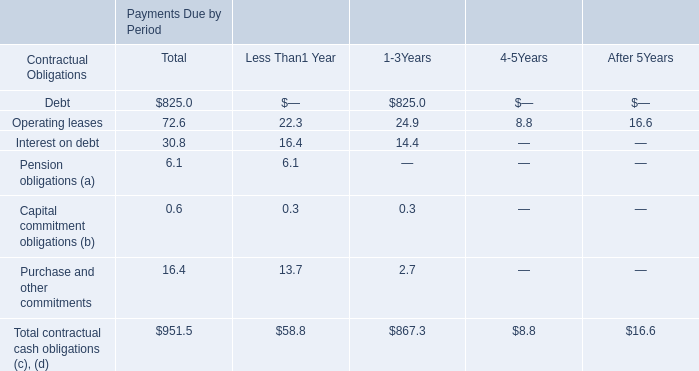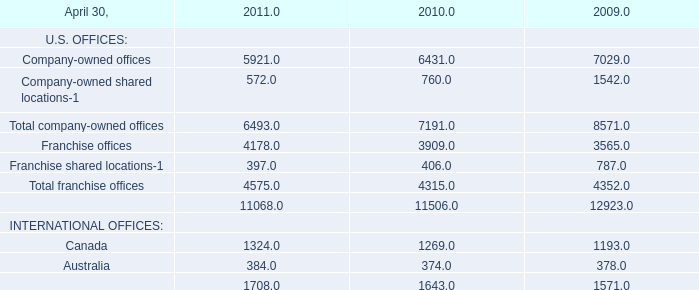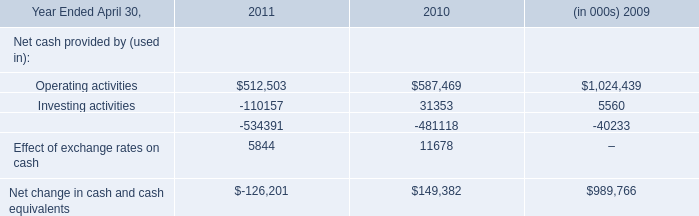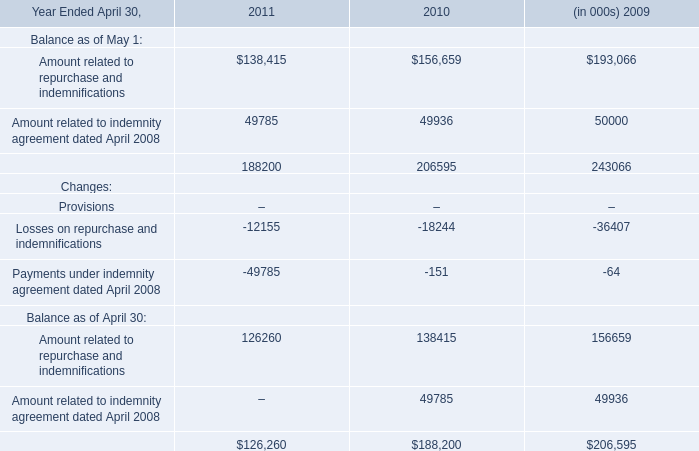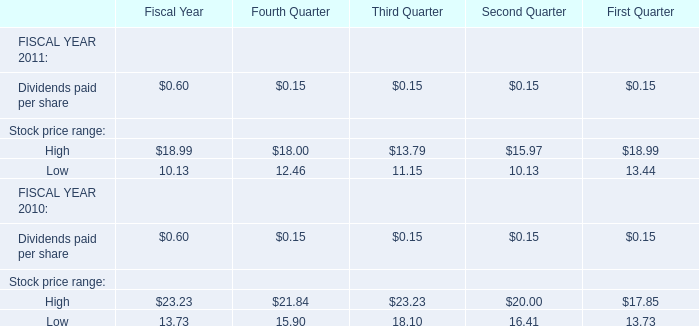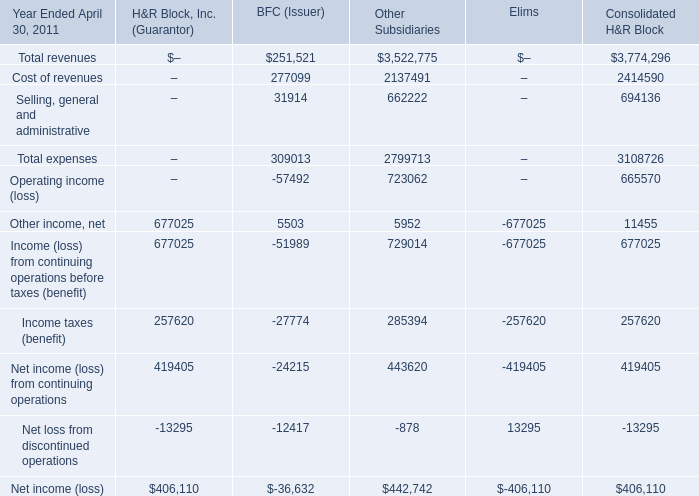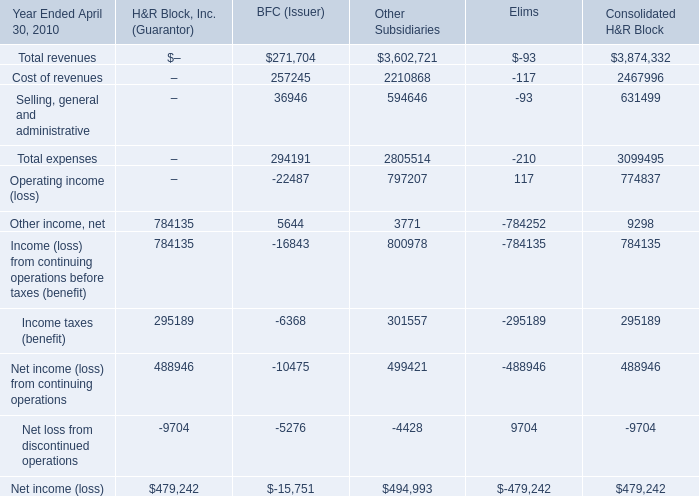Does the value of Other income, net for Elims greater than that H&R Block, Inc. (Guarantor)? 
Answer: no. 